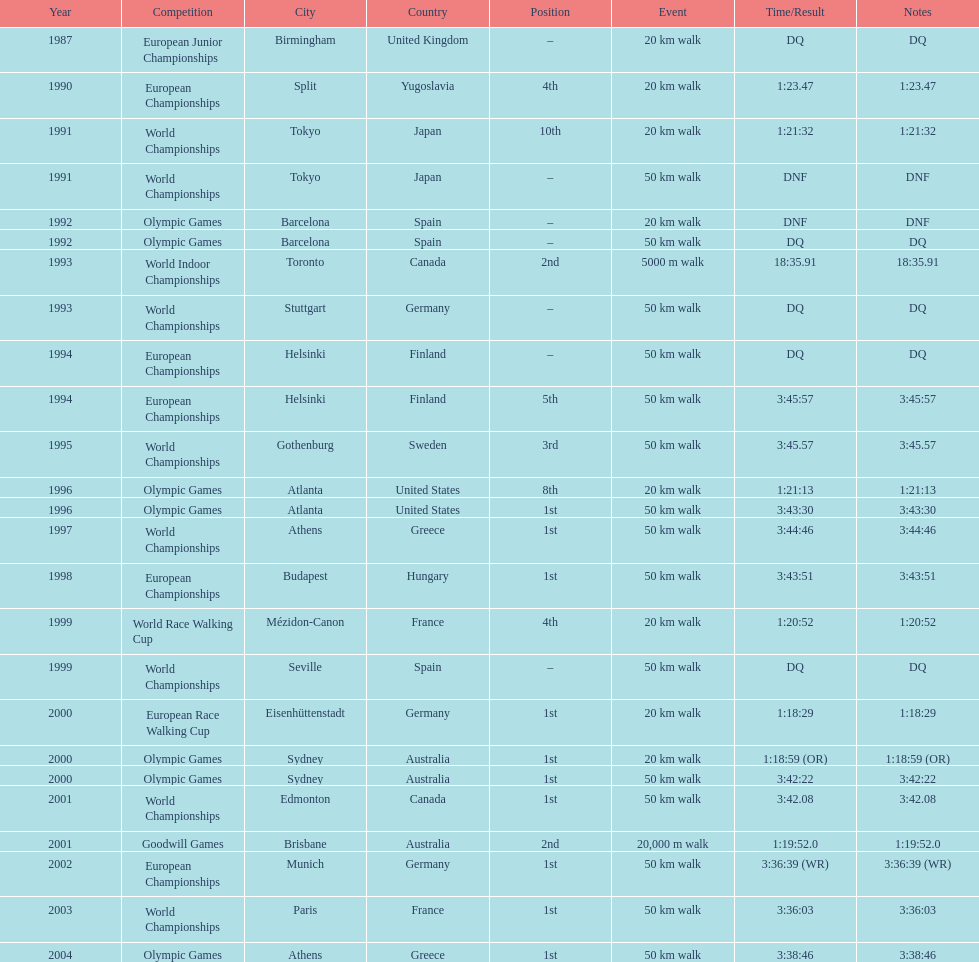How many events were at least 50 km? 17. 